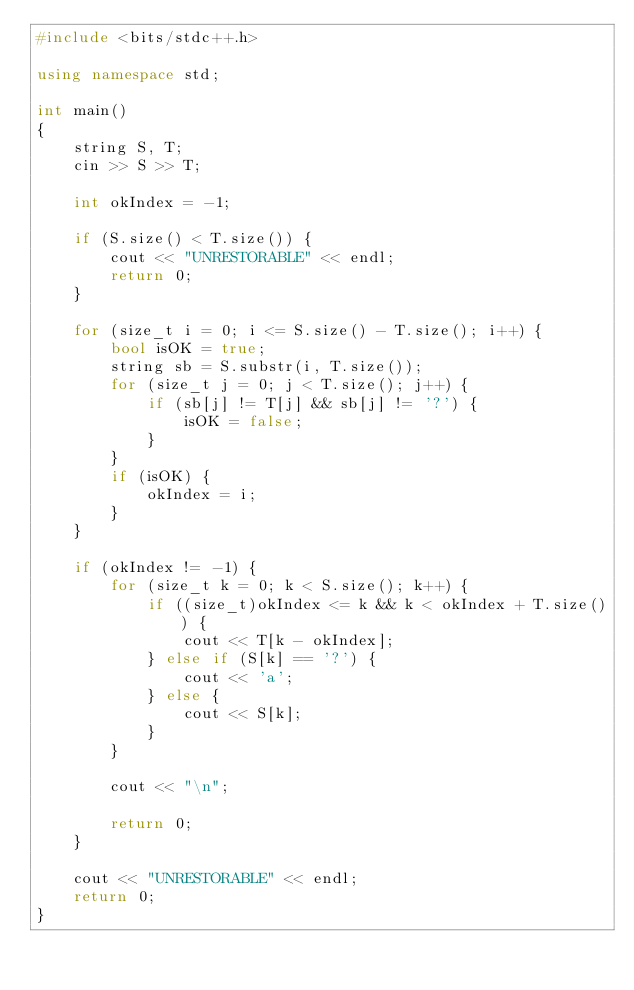Convert code to text. <code><loc_0><loc_0><loc_500><loc_500><_C++_>#include <bits/stdc++.h>

using namespace std;

int main()
{
	string S, T;
	cin >> S >> T;

	int okIndex = -1;

	if (S.size() < T.size()) {
		cout << "UNRESTORABLE" << endl;
		return 0;
	}

	for (size_t i = 0; i <= S.size() - T.size(); i++) {
		bool isOK = true;
		string sb = S.substr(i, T.size());
		for (size_t j = 0; j < T.size(); j++) {
			if (sb[j] != T[j] && sb[j] != '?') {
				isOK = false;
			}
		}
		if (isOK) {
			okIndex = i;
		}
	}

	if (okIndex != -1) {
		for (size_t k = 0; k < S.size(); k++) {
			if ((size_t)okIndex <= k && k < okIndex + T.size()) {
				cout << T[k - okIndex];
			} else if (S[k] == '?') {
				cout << 'a';
			} else {
				cout << S[k];
			}
		}

		cout << "\n";

		return 0;
	}

	cout << "UNRESTORABLE" << endl;
	return 0;
}
</code> 